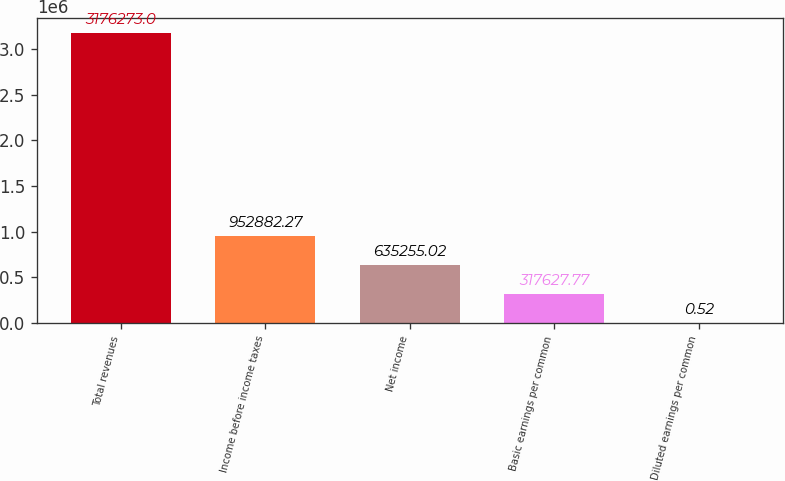<chart> <loc_0><loc_0><loc_500><loc_500><bar_chart><fcel>Total revenues<fcel>Income before income taxes<fcel>Net income<fcel>Basic earnings per common<fcel>Diluted earnings per common<nl><fcel>3.17627e+06<fcel>952882<fcel>635255<fcel>317628<fcel>0.52<nl></chart> 